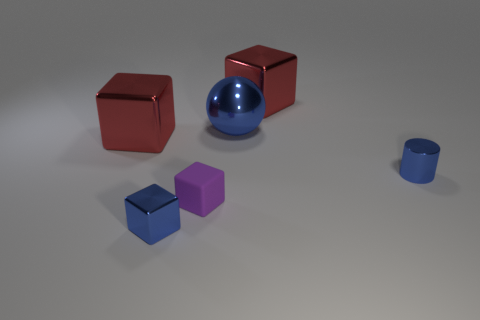Is there any other thing that is the same shape as the large blue shiny thing?
Your response must be concise. No. Is the shape of the big blue shiny thing the same as the large shiny object that is to the right of the big shiny ball?
Your answer should be compact. No. There is a red metal cube behind the red cube left of the blue metallic cube; what is its size?
Your response must be concise. Large. Is the number of blocks that are to the right of the small metal cylinder the same as the number of red blocks to the right of the rubber cube?
Your response must be concise. No. What color is the other small metal thing that is the same shape as the purple object?
Provide a short and direct response. Blue. What number of spheres have the same color as the small cylinder?
Make the answer very short. 1. Do the tiny blue metallic object right of the tiny purple rubber cube and the large blue shiny thing have the same shape?
Make the answer very short. No. There is a big red metallic thing that is behind the red metallic object that is in front of the red shiny block right of the large metallic sphere; what is its shape?
Ensure brevity in your answer.  Cube. What size is the blue cube?
Your answer should be very brief. Small. What is the color of the tiny cylinder that is made of the same material as the tiny blue block?
Your answer should be compact. Blue. 